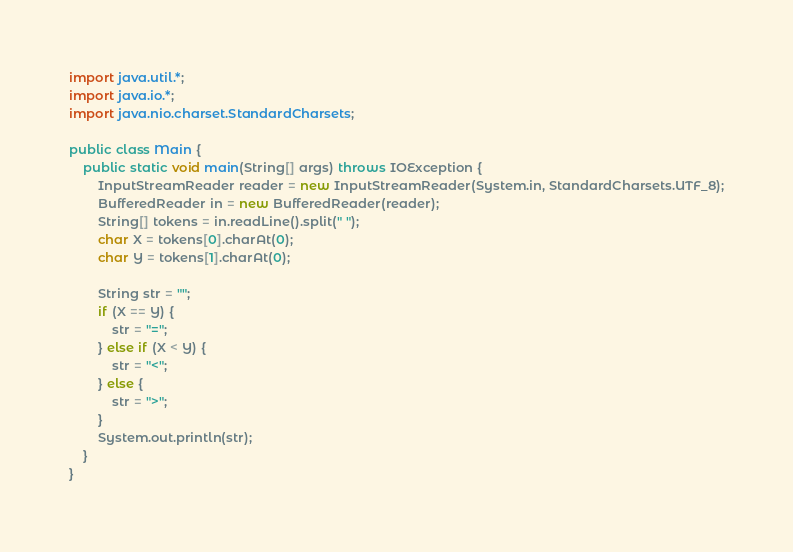<code> <loc_0><loc_0><loc_500><loc_500><_Java_>import java.util.*;
import java.io.*;
import java.nio.charset.StandardCharsets;

public class Main {
	public static void main(String[] args) throws IOException {
		InputStreamReader reader = new InputStreamReader(System.in, StandardCharsets.UTF_8);
		BufferedReader in = new BufferedReader(reader);
		String[] tokens = in.readLine().split(" ");
		char X = tokens[0].charAt(0);
		char Y = tokens[1].charAt(0);

		String str = "";
		if (X == Y) {
			str = "=";
		} else if (X < Y) {
			str = "<";
		} else {
			str = ">";
		}
		System.out.println(str);
	}
}
</code> 